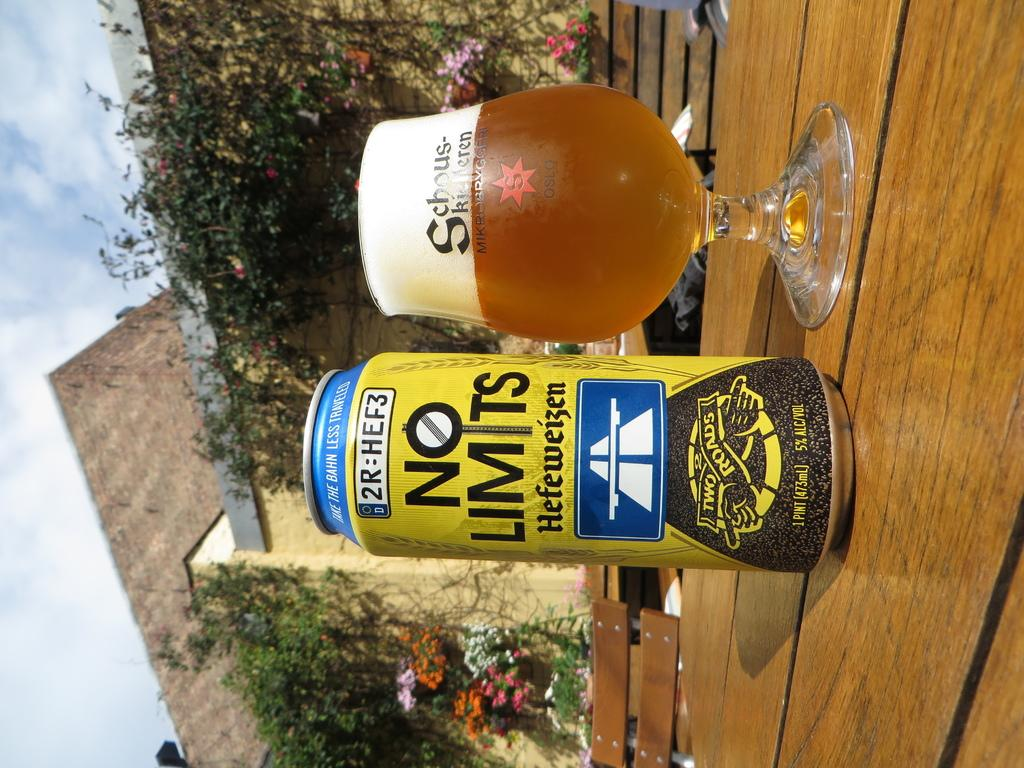<image>
Summarize the visual content of the image. A can of NO LIMITS sits on a table next to a full glass. 